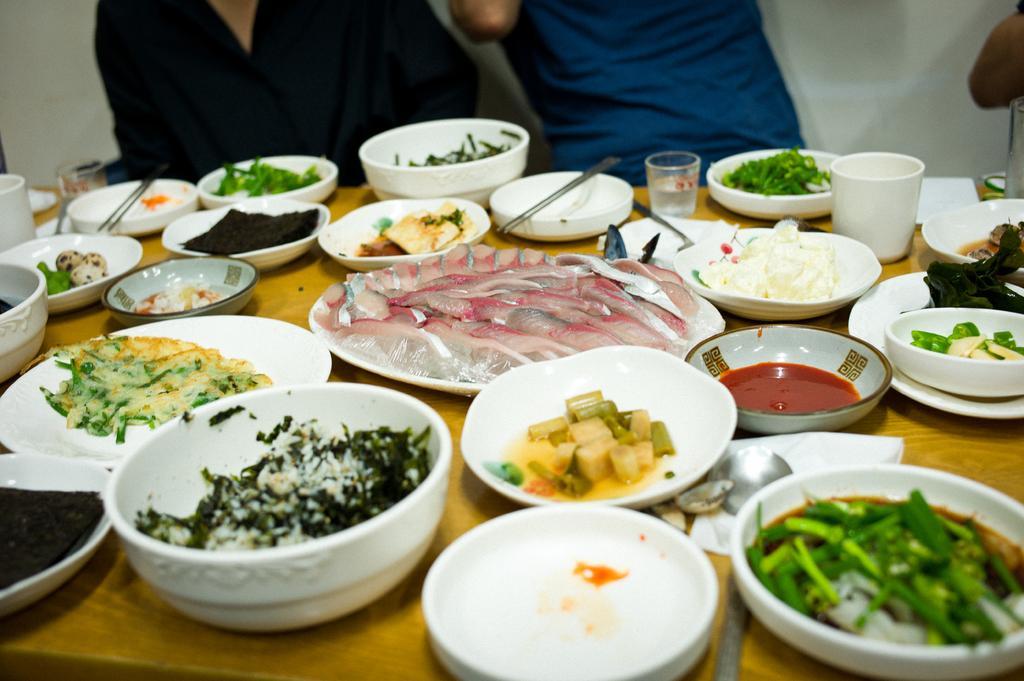Can you describe this image briefly? This is the table with the plates, bowls, glasses, spoons, tissue paper and few other things. These plates and bowls contain different types of food items. I can see two people standing. This looks like a wall. 